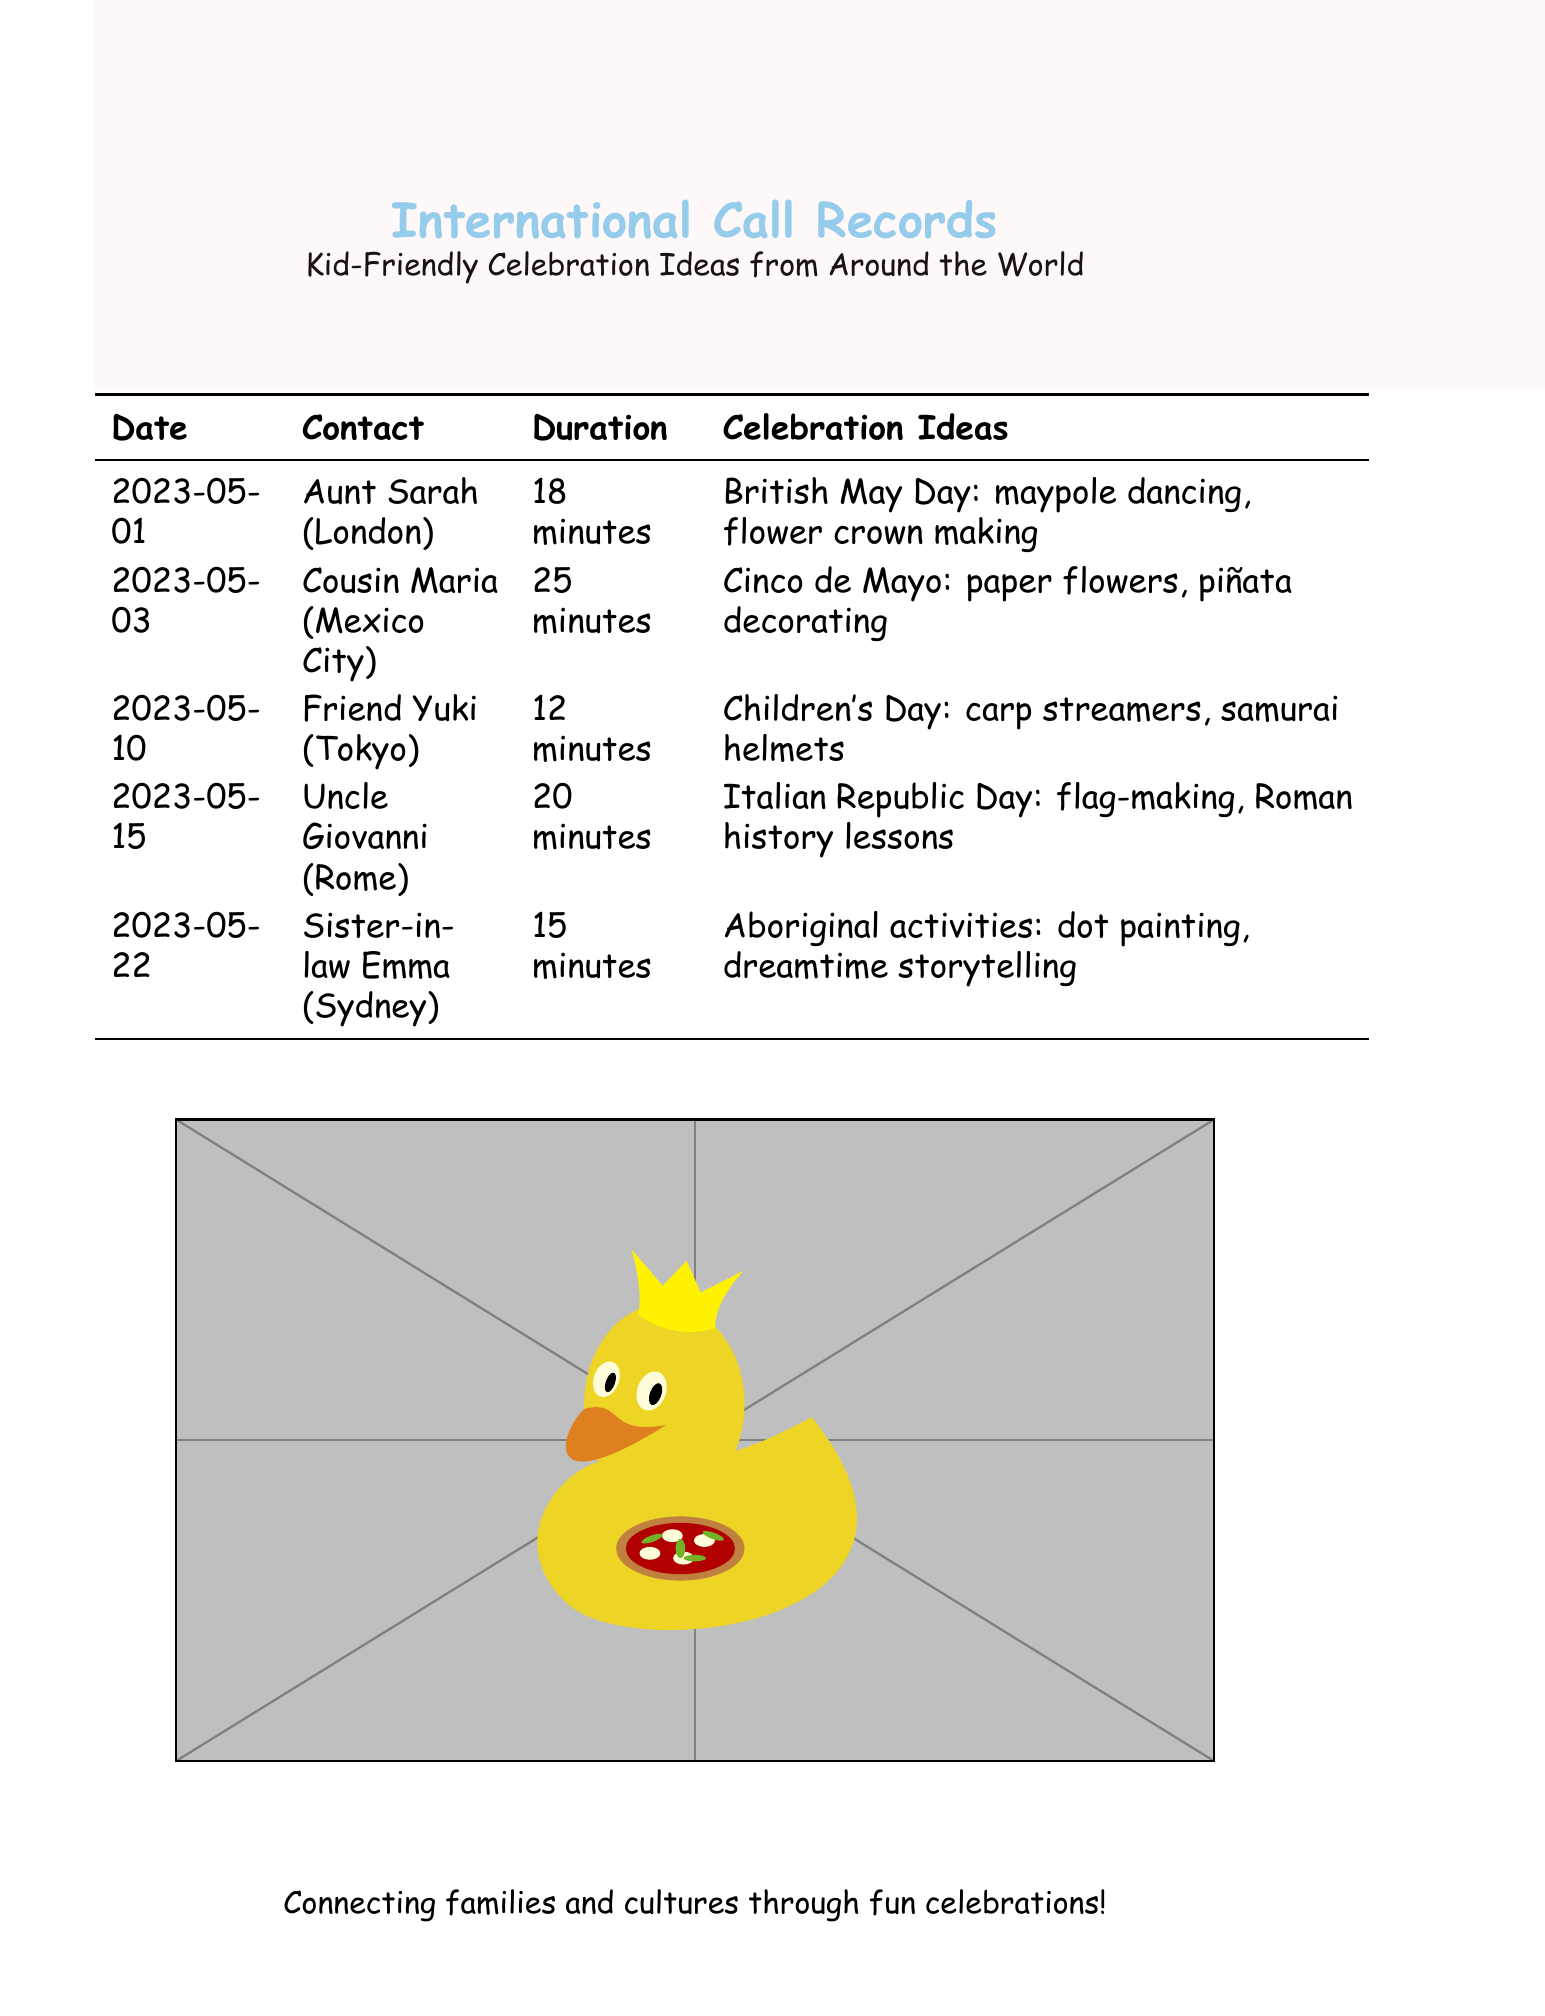What is the date of the call with Aunt Sarah? The date of the call with Aunt Sarah is listed in the document as 2023-05-01.
Answer: 2023-05-01 How long was the call with Cousin Maria? The duration of the call with Cousin Maria is shown in the document as 25 minutes.
Answer: 25 minutes What celebration idea was discussed with Friend Yuki? The celebration idea discussed with Friend Yuki is noted as carp streamers and samurai helmets for Children's Day.
Answer: carp streamers, samurai helmets Which family member is located in Rome? The family member located in Rome is specified in the document as Uncle Giovanni.
Answer: Uncle Giovanni How many minutes did the call with Sister-in-law Emma last? The call with Sister-in-law Emma lasted for 15 minutes as per the document.
Answer: 15 minutes What is one activity mentioned for Aboriginal celebrations? One activity mentioned for Aboriginal celebrations is dot painting, as included in Sister-in-law Emma's call details.
Answer: dot painting How many total calls are listed in the document? The total calls listed in the document can be counted, and there are five calls.
Answer: 5 Which celebration is related to May Day? The celebration related to May Day is identified as British May Day with specific activities.
Answer: British May Day What type of document is this? The document type is call records that include details on international calls.
Answer: international call records 